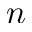Convert formula to latex. <formula><loc_0><loc_0><loc_500><loc_500>n</formula> 